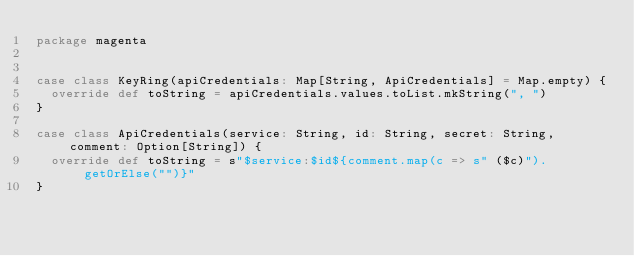Convert code to text. <code><loc_0><loc_0><loc_500><loc_500><_Scala_>package magenta


case class KeyRing(apiCredentials: Map[String, ApiCredentials] = Map.empty) {
  override def toString = apiCredentials.values.toList.mkString(", ")
}

case class ApiCredentials(service: String, id: String, secret: String, comment: Option[String]) {
  override def toString = s"$service:$id${comment.map(c => s" ($c)").getOrElse("")}"
}</code> 